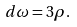Convert formula to latex. <formula><loc_0><loc_0><loc_500><loc_500>d \omega = 3 \rho .</formula> 